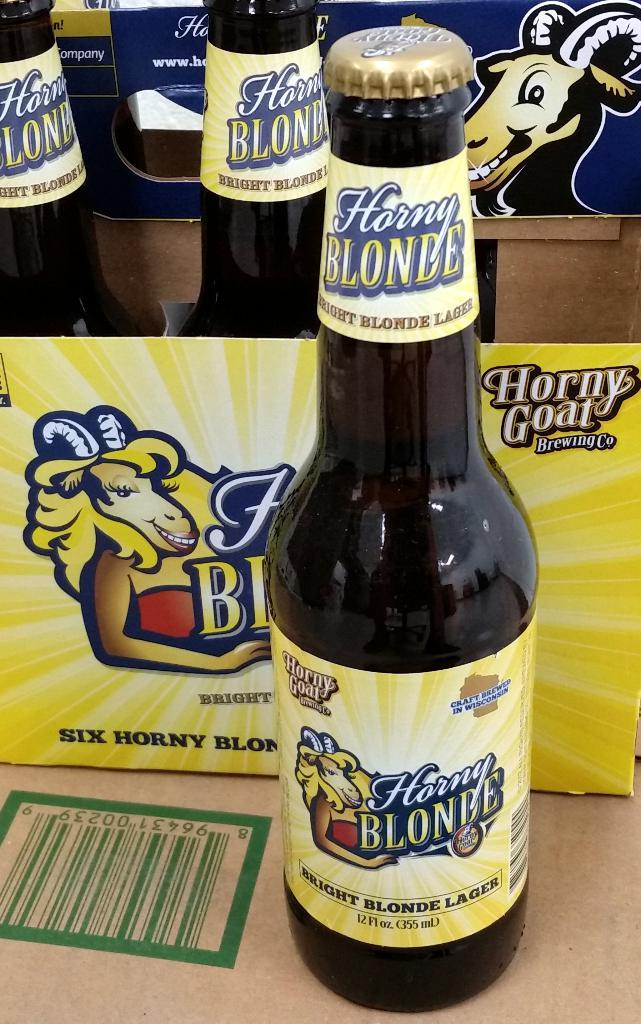Provide a one-sentence caption for the provided image. A bottle of beer from Horny Goat Brewing company is sitting next to its box. 